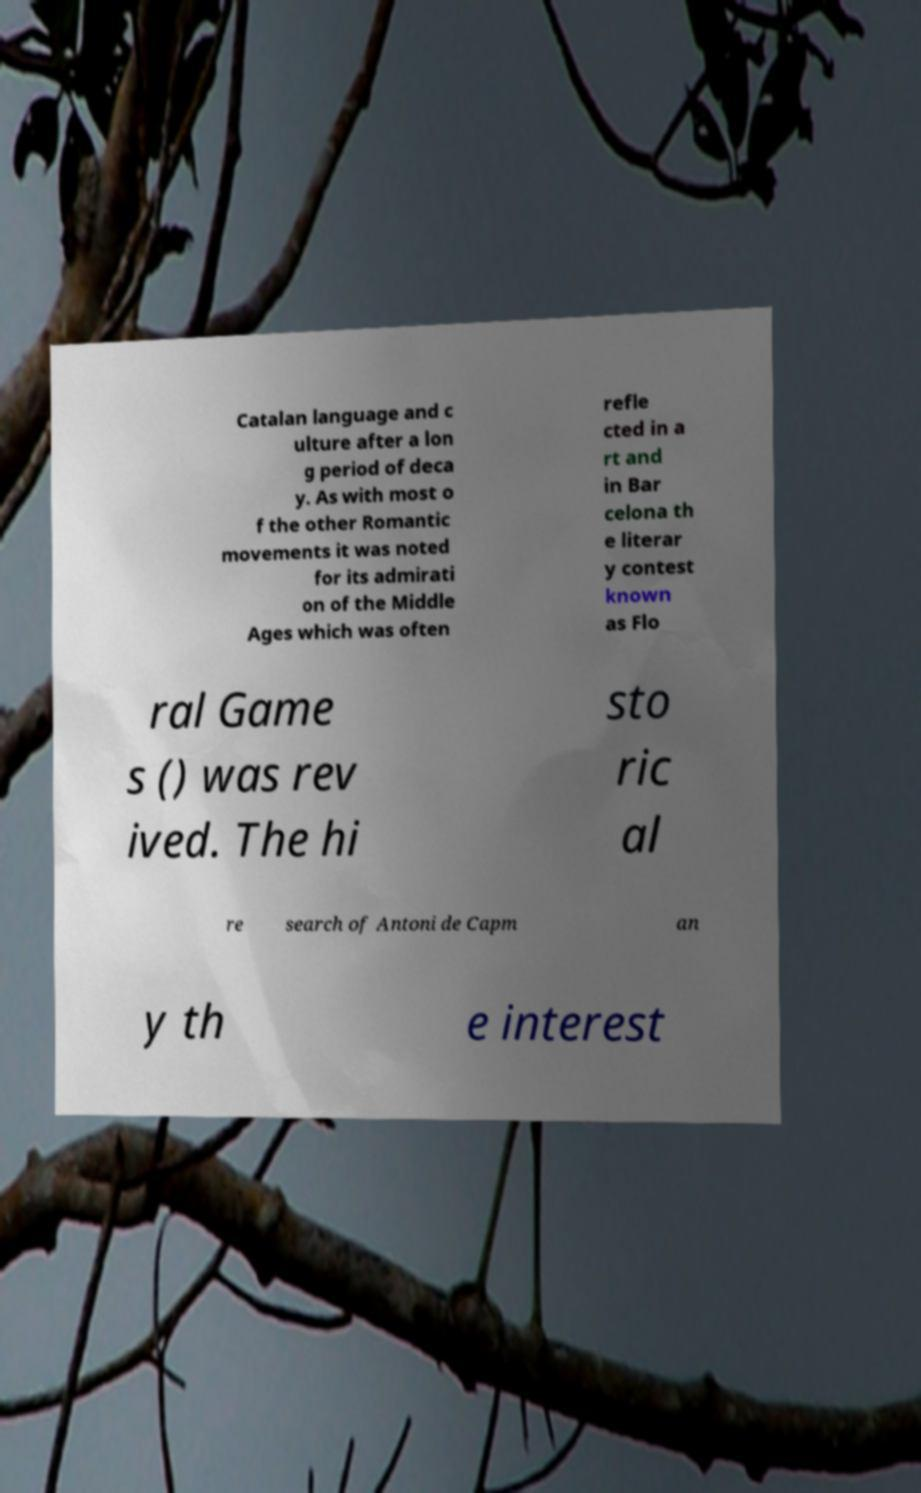Please identify and transcribe the text found in this image. Catalan language and c ulture after a lon g period of deca y. As with most o f the other Romantic movements it was noted for its admirati on of the Middle Ages which was often refle cted in a rt and in Bar celona th e literar y contest known as Flo ral Game s () was rev ived. The hi sto ric al re search of Antoni de Capm an y th e interest 